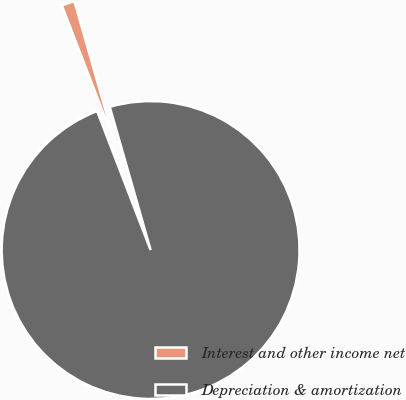Convert chart to OTSL. <chart><loc_0><loc_0><loc_500><loc_500><pie_chart><fcel>Interest and other income net<fcel>Depreciation & amortization<nl><fcel>1.42%<fcel>98.58%<nl></chart> 